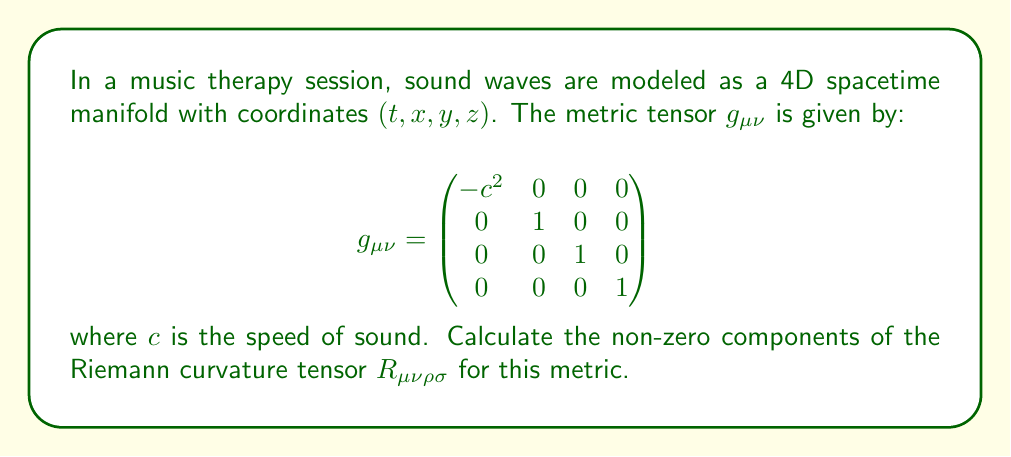Solve this math problem. To calculate the Riemann curvature tensor, we'll follow these steps:

1) First, we need to calculate the Christoffel symbols $\Gamma^\mu_{\nu\rho}$. For a metric $g_{\mu\nu}$, these are given by:

   $$\Gamma^\mu_{\nu\rho} = \frac{1}{2}g^{\mu\sigma}(\partial_\nu g_{\sigma\rho} + \partial_\rho g_{\sigma\nu} - \partial_\sigma g_{\nu\rho})$$

2) In our case, all components of the metric are constant, so all partial derivatives are zero. This means all Christoffel symbols are zero:

   $$\Gamma^\mu_{\nu\rho} = 0 \quad \text{for all } \mu, \nu, \rho$$

3) The Riemann curvature tensor is defined as:

   $$R^\mu_{\nu\rho\sigma} = \partial_\rho \Gamma^\mu_{\nu\sigma} - \partial_\sigma \Gamma^\mu_{\nu\rho} + \Gamma^\mu_{\lambda\rho}\Gamma^\lambda_{\nu\sigma} - \Gamma^\mu_{\lambda\sigma}\Gamma^\lambda_{\nu\rho}$$

4) Since all Christoffel symbols are zero, all terms in this expression are zero:

   $$R^\mu_{\nu\rho\sigma} = 0 \quad \text{for all } \mu, \nu, \rho, \sigma$$

5) To get $R_{\mu\nu\rho\sigma}$, we lower the first index using the metric:

   $$R_{\mu\nu\rho\sigma} = g_{\mu\lambda}R^\lambda_{\nu\rho\sigma} = 0 \quad \text{for all } \mu, \nu, \rho, \sigma$$

Therefore, all components of the Riemann curvature tensor are zero for this metric.
Answer: $R_{\mu\nu\rho\sigma} = 0$ for all $\mu, \nu, \rho, \sigma$ 